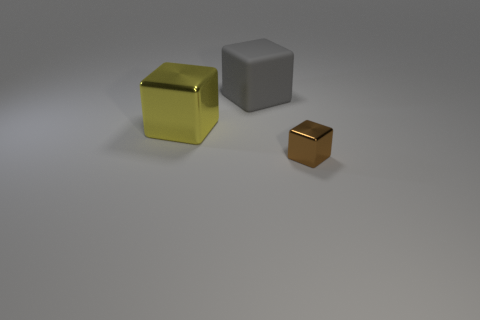Is the number of yellow blocks to the right of the large gray rubber cube the same as the number of big yellow things on the left side of the big yellow metal thing?
Keep it short and to the point. Yes. What color is the other tiny object that is the same shape as the gray thing?
Keep it short and to the point. Brown. Do the shiny object that is to the left of the small metal object and the tiny brown object have the same shape?
Provide a succinct answer. Yes. What is the shape of the object behind the thing that is to the left of the large cube that is to the right of the large yellow metallic block?
Keep it short and to the point. Cube. What is the size of the yellow thing?
Ensure brevity in your answer.  Large. There is another block that is made of the same material as the yellow cube; what color is it?
Offer a very short reply. Brown. How many other small cubes have the same material as the yellow block?
Give a very brief answer. 1. There is a shiny block left of the metallic cube in front of the big yellow metallic thing; what color is it?
Provide a short and direct response. Yellow. There is a rubber thing that is the same size as the yellow block; what color is it?
Provide a succinct answer. Gray. Is there another brown shiny thing that has the same shape as the tiny brown metallic thing?
Your response must be concise. No. 